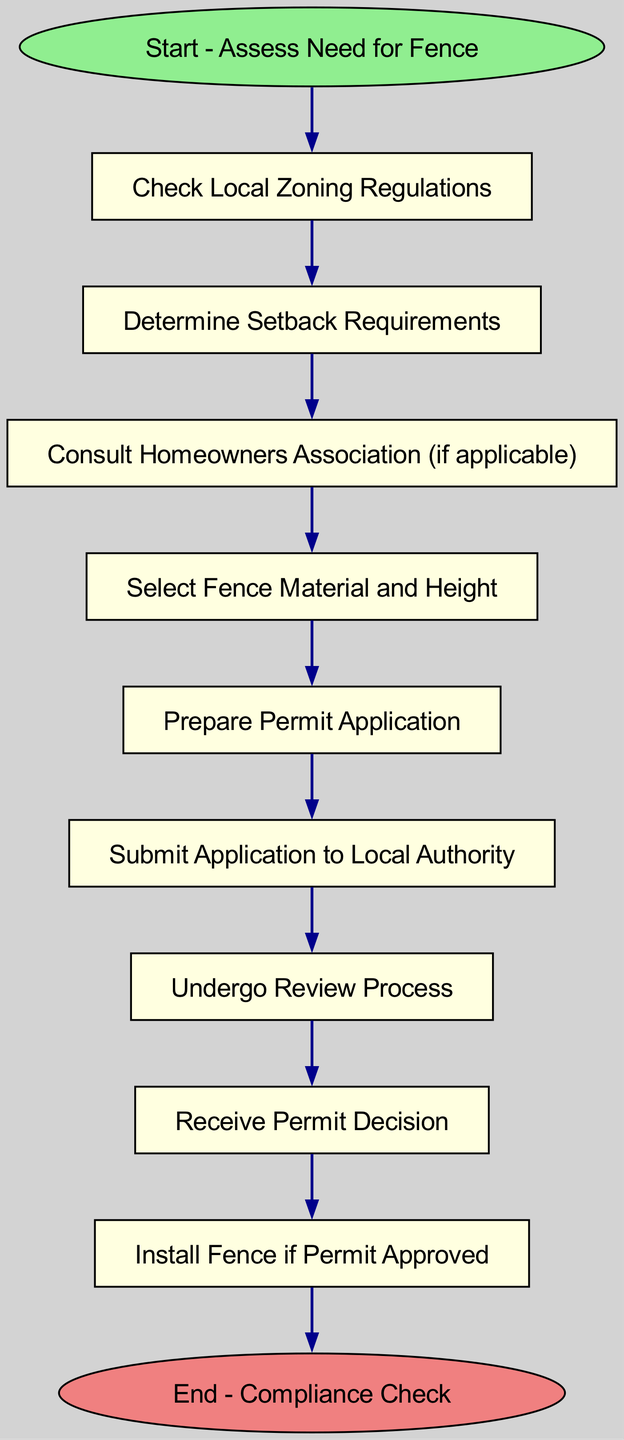What is the first step in the permit application process? The first step in the process is indicated as "Start - Assess Need for Fence." This is the starting point of the flow chart, which sets the context for the following steps in the application process.
Answer: Start - Assess Need for Fence How many nodes are in the flow chart? To find the total number of nodes, we count each distinct step in the flow chart from start to end. There are 11 nodes altogether: "Start - Assess Need for Fence," "Check Local Zoning Regulations," "Determine Setback Requirements," "Consult Homeowners Association (if applicable)," "Select Fence Material and Height," "Prepare Permit Application," "Submit Application to Local Authority," "Undergo Review Process," "Receive Permit Decision," "Install Fence if Permit Approved," and "End - Compliance Check."
Answer: 11 What comes after "Consult Homeowners Association (if applicable)"? Following "Consult Homeowners Association (if applicable)," the next node in the flow chart is "Select Fence Material and Height." This indicates that after consulting the association, the next step focuses on the specifics of the fence being considered.
Answer: Select Fence Material and Height What is the last step in the permit application process? The last step in the flow chart is labeled "End - Compliance Check," which indicates that the process concludes with a check to ensure compliance with regulations post-installation.
Answer: End - Compliance Check If the application is approved, what task follows? Upon receiving an approved permit, the next task is to "Install Fence if Permit Approved." This follows the permit decision, indicating the action to take after receiving approval.
Answer: Install Fence if Permit Approved Which step involves preparing necessary documentation? The step that involves preparing documentation is "Prepare Permit Application." This is a critical task that involves compiling all necessary forms and information required for the permit submission.
Answer: Prepare Permit Application How does one begin the process to install a fence? One begins the process to install a fence by taking the initial action labeled "Start - Assess Need for Fence," which identifies the intention to install a fence as the starting point for the entire process.
Answer: Start - Assess Need for Fence Which node requires checking local laws? The node that requires checking local laws is "Check Local Zoning Regulations." This step ensures that the intended fence installation adheres to any local zoning laws that may apply.
Answer: Check Local Zoning Regulations 